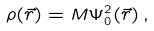<formula> <loc_0><loc_0><loc_500><loc_500>\rho ( \vec { r } ) = M \Psi _ { 0 } ^ { 2 } ( \vec { r } ) \, ,</formula> 